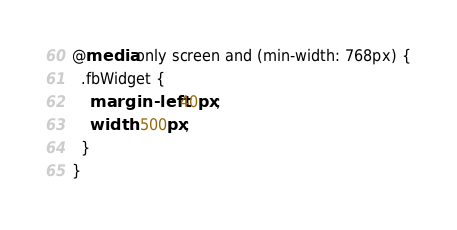<code> <loc_0><loc_0><loc_500><loc_500><_CSS_>@media only screen and (min-width: 768px) {
  .fbWidget {
    margin-left: 40px;
    width: 500px;
  }
}
</code> 